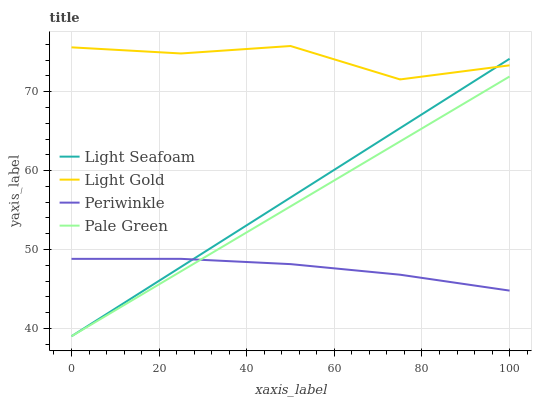Does Periwinkle have the minimum area under the curve?
Answer yes or no. Yes. Does Light Gold have the maximum area under the curve?
Answer yes or no. Yes. Does Pale Green have the minimum area under the curve?
Answer yes or no. No. Does Pale Green have the maximum area under the curve?
Answer yes or no. No. Is Light Seafoam the smoothest?
Answer yes or no. Yes. Is Light Gold the roughest?
Answer yes or no. Yes. Is Pale Green the smoothest?
Answer yes or no. No. Is Pale Green the roughest?
Answer yes or no. No. Does Pale Green have the lowest value?
Answer yes or no. Yes. Does Light Gold have the lowest value?
Answer yes or no. No. Does Light Gold have the highest value?
Answer yes or no. Yes. Does Pale Green have the highest value?
Answer yes or no. No. Is Periwinkle less than Light Gold?
Answer yes or no. Yes. Is Light Gold greater than Periwinkle?
Answer yes or no. Yes. Does Pale Green intersect Light Seafoam?
Answer yes or no. Yes. Is Pale Green less than Light Seafoam?
Answer yes or no. No. Is Pale Green greater than Light Seafoam?
Answer yes or no. No. Does Periwinkle intersect Light Gold?
Answer yes or no. No. 